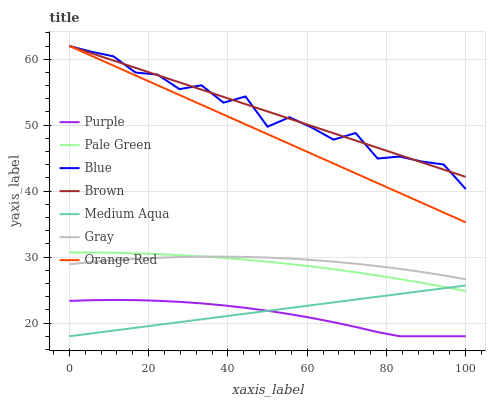Does Purple have the minimum area under the curve?
Answer yes or no. Yes. Does Brown have the maximum area under the curve?
Answer yes or no. Yes. Does Gray have the minimum area under the curve?
Answer yes or no. No. Does Gray have the maximum area under the curve?
Answer yes or no. No. Is Medium Aqua the smoothest?
Answer yes or no. Yes. Is Blue the roughest?
Answer yes or no. Yes. Is Gray the smoothest?
Answer yes or no. No. Is Gray the roughest?
Answer yes or no. No. Does Gray have the lowest value?
Answer yes or no. No. Does Orange Red have the highest value?
Answer yes or no. Yes. Does Gray have the highest value?
Answer yes or no. No. Is Purple less than Brown?
Answer yes or no. Yes. Is Orange Red greater than Medium Aqua?
Answer yes or no. Yes. Does Brown intersect Orange Red?
Answer yes or no. Yes. Is Brown less than Orange Red?
Answer yes or no. No. Is Brown greater than Orange Red?
Answer yes or no. No. Does Purple intersect Brown?
Answer yes or no. No. 